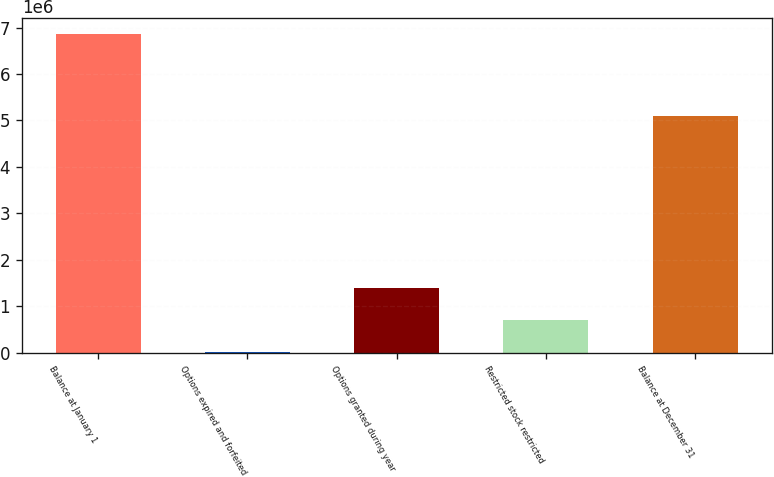Convert chart. <chart><loc_0><loc_0><loc_500><loc_500><bar_chart><fcel>Balance at January 1<fcel>Options expired and forfeited<fcel>Options granted during year<fcel>Restricted stock restricted<fcel>Balance at December 31<nl><fcel>6.87228e+06<fcel>8518<fcel>1.38127e+06<fcel>694894<fcel>5.08846e+06<nl></chart> 